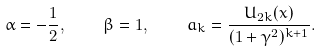Convert formula to latex. <formula><loc_0><loc_0><loc_500><loc_500>\alpha = - \frac { 1 } { 2 } , \quad \beta = 1 , \quad a _ { k } = \frac { U _ { 2 k } ( x ) } { ( 1 + \gamma ^ { 2 } ) ^ { k + 1 } } .</formula> 